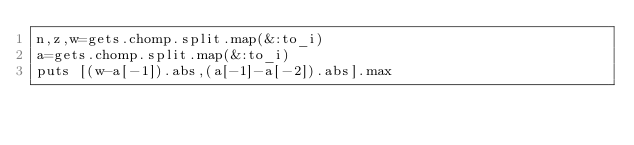<code> <loc_0><loc_0><loc_500><loc_500><_Ruby_>n,z,w=gets.chomp.split.map(&:to_i)
a=gets.chomp.split.map(&:to_i)
puts [(w-a[-1]).abs,(a[-1]-a[-2]).abs].max</code> 